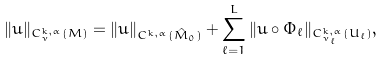<formula> <loc_0><loc_0><loc_500><loc_500>\| u \| _ { C ^ { k , \alpha } _ { \nu } ( M ) } = \| u \| _ { C ^ { k , \alpha } ( \hat { M } _ { 0 } ) } + \sum _ { \ell = 1 } ^ { L } \| u \circ \Phi _ { \ell } \| _ { C ^ { k , \alpha } _ { \nu _ { \ell } } ( U _ { \ell } ) } ,</formula> 